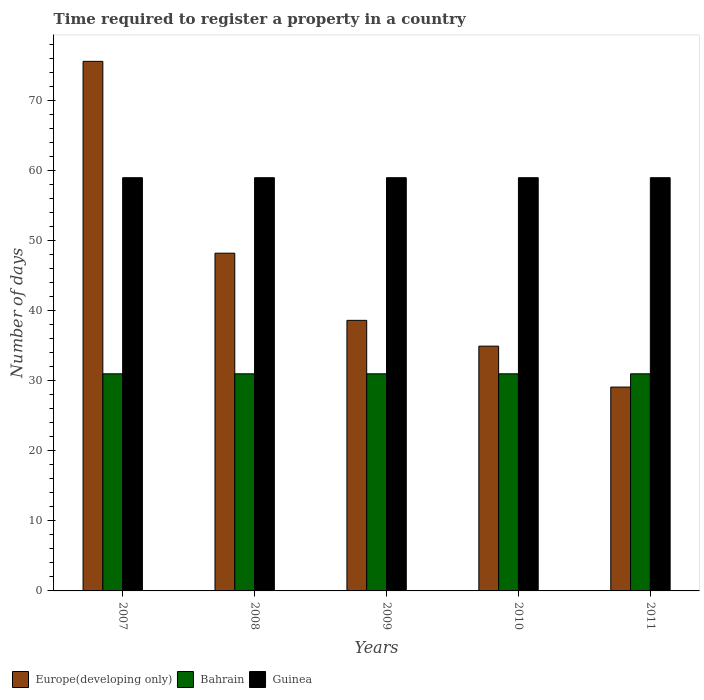How many bars are there on the 3rd tick from the right?
Your response must be concise. 3. What is the number of days required to register a property in Bahrain in 2007?
Your response must be concise. 31. Across all years, what is the maximum number of days required to register a property in Guinea?
Provide a succinct answer. 59. Across all years, what is the minimum number of days required to register a property in Europe(developing only)?
Make the answer very short. 29.11. In which year was the number of days required to register a property in Europe(developing only) maximum?
Your response must be concise. 2007. In which year was the number of days required to register a property in Europe(developing only) minimum?
Provide a short and direct response. 2011. What is the total number of days required to register a property in Europe(developing only) in the graph?
Give a very brief answer. 226.52. What is the difference between the number of days required to register a property in Bahrain in 2007 and the number of days required to register a property in Europe(developing only) in 2009?
Your answer should be compact. -7.63. In the year 2009, what is the difference between the number of days required to register a property in Europe(developing only) and number of days required to register a property in Guinea?
Make the answer very short. -20.37. In how many years, is the number of days required to register a property in Bahrain greater than 62 days?
Your response must be concise. 0. Is the number of days required to register a property in Guinea in 2008 less than that in 2009?
Give a very brief answer. No. Is the difference between the number of days required to register a property in Europe(developing only) in 2008 and 2010 greater than the difference between the number of days required to register a property in Guinea in 2008 and 2010?
Provide a short and direct response. Yes. What is the difference between the highest and the second highest number of days required to register a property in Europe(developing only)?
Your answer should be compact. 27.39. In how many years, is the number of days required to register a property in Europe(developing only) greater than the average number of days required to register a property in Europe(developing only) taken over all years?
Keep it short and to the point. 2. What does the 1st bar from the left in 2011 represents?
Your response must be concise. Europe(developing only). What does the 1st bar from the right in 2009 represents?
Provide a succinct answer. Guinea. How many bars are there?
Make the answer very short. 15. What is the difference between two consecutive major ticks on the Y-axis?
Provide a succinct answer. 10. Are the values on the major ticks of Y-axis written in scientific E-notation?
Make the answer very short. No. Where does the legend appear in the graph?
Offer a very short reply. Bottom left. How many legend labels are there?
Your answer should be very brief. 3. What is the title of the graph?
Provide a succinct answer. Time required to register a property in a country. What is the label or title of the X-axis?
Provide a short and direct response. Years. What is the label or title of the Y-axis?
Keep it short and to the point. Number of days. What is the Number of days of Europe(developing only) in 2007?
Ensure brevity in your answer.  75.61. What is the Number of days in Bahrain in 2007?
Offer a very short reply. 31. What is the Number of days in Guinea in 2007?
Your response must be concise. 59. What is the Number of days of Europe(developing only) in 2008?
Make the answer very short. 48.22. What is the Number of days of Bahrain in 2008?
Your answer should be very brief. 31. What is the Number of days of Europe(developing only) in 2009?
Provide a short and direct response. 38.63. What is the Number of days in Guinea in 2009?
Keep it short and to the point. 59. What is the Number of days of Europe(developing only) in 2010?
Give a very brief answer. 34.95. What is the Number of days of Guinea in 2010?
Keep it short and to the point. 59. What is the Number of days in Europe(developing only) in 2011?
Offer a terse response. 29.11. What is the Number of days in Guinea in 2011?
Your answer should be compact. 59. Across all years, what is the maximum Number of days of Europe(developing only)?
Ensure brevity in your answer.  75.61. Across all years, what is the maximum Number of days of Bahrain?
Give a very brief answer. 31. Across all years, what is the minimum Number of days in Europe(developing only)?
Provide a short and direct response. 29.11. What is the total Number of days of Europe(developing only) in the graph?
Keep it short and to the point. 226.52. What is the total Number of days of Bahrain in the graph?
Keep it short and to the point. 155. What is the total Number of days in Guinea in the graph?
Keep it short and to the point. 295. What is the difference between the Number of days in Europe(developing only) in 2007 and that in 2008?
Keep it short and to the point. 27.39. What is the difference between the Number of days in Bahrain in 2007 and that in 2008?
Ensure brevity in your answer.  0. What is the difference between the Number of days of Guinea in 2007 and that in 2008?
Offer a terse response. 0. What is the difference between the Number of days of Europe(developing only) in 2007 and that in 2009?
Provide a succinct answer. 36.98. What is the difference between the Number of days in Europe(developing only) in 2007 and that in 2010?
Give a very brief answer. 40.66. What is the difference between the Number of days in Europe(developing only) in 2007 and that in 2011?
Make the answer very short. 46.51. What is the difference between the Number of days of Bahrain in 2007 and that in 2011?
Offer a very short reply. 0. What is the difference between the Number of days in Guinea in 2007 and that in 2011?
Give a very brief answer. 0. What is the difference between the Number of days of Europe(developing only) in 2008 and that in 2009?
Offer a terse response. 9.59. What is the difference between the Number of days in Bahrain in 2008 and that in 2009?
Keep it short and to the point. 0. What is the difference between the Number of days in Europe(developing only) in 2008 and that in 2010?
Your response must be concise. 13.27. What is the difference between the Number of days in Bahrain in 2008 and that in 2010?
Your response must be concise. 0. What is the difference between the Number of days in Guinea in 2008 and that in 2010?
Offer a very short reply. 0. What is the difference between the Number of days of Europe(developing only) in 2008 and that in 2011?
Offer a terse response. 19.12. What is the difference between the Number of days in Bahrain in 2008 and that in 2011?
Your answer should be compact. 0. What is the difference between the Number of days in Europe(developing only) in 2009 and that in 2010?
Give a very brief answer. 3.68. What is the difference between the Number of days of Europe(developing only) in 2009 and that in 2011?
Make the answer very short. 9.53. What is the difference between the Number of days in Bahrain in 2009 and that in 2011?
Provide a short and direct response. 0. What is the difference between the Number of days in Europe(developing only) in 2010 and that in 2011?
Provide a succinct answer. 5.84. What is the difference between the Number of days in Europe(developing only) in 2007 and the Number of days in Bahrain in 2008?
Offer a very short reply. 44.61. What is the difference between the Number of days of Europe(developing only) in 2007 and the Number of days of Guinea in 2008?
Offer a terse response. 16.61. What is the difference between the Number of days in Europe(developing only) in 2007 and the Number of days in Bahrain in 2009?
Your answer should be very brief. 44.61. What is the difference between the Number of days of Europe(developing only) in 2007 and the Number of days of Guinea in 2009?
Provide a succinct answer. 16.61. What is the difference between the Number of days of Bahrain in 2007 and the Number of days of Guinea in 2009?
Offer a very short reply. -28. What is the difference between the Number of days in Europe(developing only) in 2007 and the Number of days in Bahrain in 2010?
Offer a very short reply. 44.61. What is the difference between the Number of days in Europe(developing only) in 2007 and the Number of days in Guinea in 2010?
Make the answer very short. 16.61. What is the difference between the Number of days in Bahrain in 2007 and the Number of days in Guinea in 2010?
Make the answer very short. -28. What is the difference between the Number of days of Europe(developing only) in 2007 and the Number of days of Bahrain in 2011?
Ensure brevity in your answer.  44.61. What is the difference between the Number of days in Europe(developing only) in 2007 and the Number of days in Guinea in 2011?
Offer a terse response. 16.61. What is the difference between the Number of days of Europe(developing only) in 2008 and the Number of days of Bahrain in 2009?
Ensure brevity in your answer.  17.22. What is the difference between the Number of days of Europe(developing only) in 2008 and the Number of days of Guinea in 2009?
Provide a succinct answer. -10.78. What is the difference between the Number of days in Bahrain in 2008 and the Number of days in Guinea in 2009?
Keep it short and to the point. -28. What is the difference between the Number of days of Europe(developing only) in 2008 and the Number of days of Bahrain in 2010?
Provide a short and direct response. 17.22. What is the difference between the Number of days of Europe(developing only) in 2008 and the Number of days of Guinea in 2010?
Give a very brief answer. -10.78. What is the difference between the Number of days of Bahrain in 2008 and the Number of days of Guinea in 2010?
Ensure brevity in your answer.  -28. What is the difference between the Number of days of Europe(developing only) in 2008 and the Number of days of Bahrain in 2011?
Give a very brief answer. 17.22. What is the difference between the Number of days in Europe(developing only) in 2008 and the Number of days in Guinea in 2011?
Offer a very short reply. -10.78. What is the difference between the Number of days of Europe(developing only) in 2009 and the Number of days of Bahrain in 2010?
Keep it short and to the point. 7.63. What is the difference between the Number of days of Europe(developing only) in 2009 and the Number of days of Guinea in 2010?
Your answer should be compact. -20.37. What is the difference between the Number of days of Europe(developing only) in 2009 and the Number of days of Bahrain in 2011?
Your response must be concise. 7.63. What is the difference between the Number of days in Europe(developing only) in 2009 and the Number of days in Guinea in 2011?
Ensure brevity in your answer.  -20.37. What is the difference between the Number of days in Europe(developing only) in 2010 and the Number of days in Bahrain in 2011?
Offer a very short reply. 3.95. What is the difference between the Number of days of Europe(developing only) in 2010 and the Number of days of Guinea in 2011?
Offer a terse response. -24.05. What is the average Number of days of Europe(developing only) per year?
Your response must be concise. 45.3. What is the average Number of days of Bahrain per year?
Ensure brevity in your answer.  31. What is the average Number of days in Guinea per year?
Your answer should be compact. 59. In the year 2007, what is the difference between the Number of days of Europe(developing only) and Number of days of Bahrain?
Your answer should be very brief. 44.61. In the year 2007, what is the difference between the Number of days in Europe(developing only) and Number of days in Guinea?
Keep it short and to the point. 16.61. In the year 2007, what is the difference between the Number of days in Bahrain and Number of days in Guinea?
Ensure brevity in your answer.  -28. In the year 2008, what is the difference between the Number of days of Europe(developing only) and Number of days of Bahrain?
Your answer should be very brief. 17.22. In the year 2008, what is the difference between the Number of days of Europe(developing only) and Number of days of Guinea?
Offer a terse response. -10.78. In the year 2009, what is the difference between the Number of days of Europe(developing only) and Number of days of Bahrain?
Ensure brevity in your answer.  7.63. In the year 2009, what is the difference between the Number of days of Europe(developing only) and Number of days of Guinea?
Offer a very short reply. -20.37. In the year 2009, what is the difference between the Number of days of Bahrain and Number of days of Guinea?
Make the answer very short. -28. In the year 2010, what is the difference between the Number of days in Europe(developing only) and Number of days in Bahrain?
Ensure brevity in your answer.  3.95. In the year 2010, what is the difference between the Number of days in Europe(developing only) and Number of days in Guinea?
Ensure brevity in your answer.  -24.05. In the year 2010, what is the difference between the Number of days of Bahrain and Number of days of Guinea?
Offer a terse response. -28. In the year 2011, what is the difference between the Number of days of Europe(developing only) and Number of days of Bahrain?
Give a very brief answer. -1.89. In the year 2011, what is the difference between the Number of days of Europe(developing only) and Number of days of Guinea?
Provide a short and direct response. -29.89. In the year 2011, what is the difference between the Number of days of Bahrain and Number of days of Guinea?
Provide a short and direct response. -28. What is the ratio of the Number of days of Europe(developing only) in 2007 to that in 2008?
Make the answer very short. 1.57. What is the ratio of the Number of days in Bahrain in 2007 to that in 2008?
Provide a succinct answer. 1. What is the ratio of the Number of days of Guinea in 2007 to that in 2008?
Your answer should be very brief. 1. What is the ratio of the Number of days in Europe(developing only) in 2007 to that in 2009?
Keep it short and to the point. 1.96. What is the ratio of the Number of days of Guinea in 2007 to that in 2009?
Provide a succinct answer. 1. What is the ratio of the Number of days in Europe(developing only) in 2007 to that in 2010?
Ensure brevity in your answer.  2.16. What is the ratio of the Number of days of Bahrain in 2007 to that in 2010?
Offer a terse response. 1. What is the ratio of the Number of days in Europe(developing only) in 2007 to that in 2011?
Keep it short and to the point. 2.6. What is the ratio of the Number of days in Europe(developing only) in 2008 to that in 2009?
Make the answer very short. 1.25. What is the ratio of the Number of days in Europe(developing only) in 2008 to that in 2010?
Keep it short and to the point. 1.38. What is the ratio of the Number of days in Europe(developing only) in 2008 to that in 2011?
Offer a terse response. 1.66. What is the ratio of the Number of days in Bahrain in 2008 to that in 2011?
Keep it short and to the point. 1. What is the ratio of the Number of days of Guinea in 2008 to that in 2011?
Your response must be concise. 1. What is the ratio of the Number of days of Europe(developing only) in 2009 to that in 2010?
Your response must be concise. 1.11. What is the ratio of the Number of days of Bahrain in 2009 to that in 2010?
Give a very brief answer. 1. What is the ratio of the Number of days of Europe(developing only) in 2009 to that in 2011?
Your answer should be very brief. 1.33. What is the ratio of the Number of days in Europe(developing only) in 2010 to that in 2011?
Give a very brief answer. 1.2. What is the ratio of the Number of days of Bahrain in 2010 to that in 2011?
Make the answer very short. 1. What is the difference between the highest and the second highest Number of days of Europe(developing only)?
Your answer should be compact. 27.39. What is the difference between the highest and the lowest Number of days of Europe(developing only)?
Offer a terse response. 46.51. What is the difference between the highest and the lowest Number of days in Bahrain?
Your answer should be very brief. 0. 